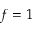Convert formula to latex. <formula><loc_0><loc_0><loc_500><loc_500>f = 1</formula> 